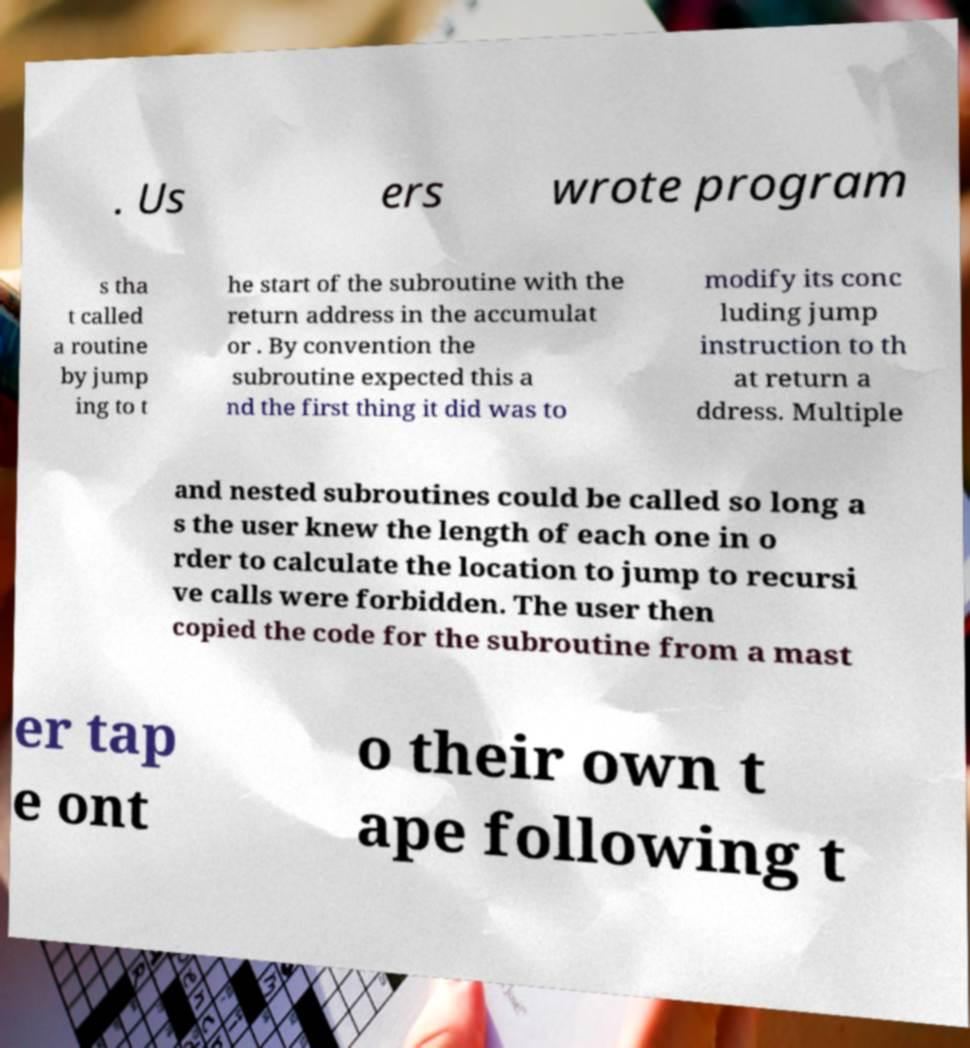Could you extract and type out the text from this image? . Us ers wrote program s tha t called a routine by jump ing to t he start of the subroutine with the return address in the accumulat or . By convention the subroutine expected this a nd the first thing it did was to modify its conc luding jump instruction to th at return a ddress. Multiple and nested subroutines could be called so long a s the user knew the length of each one in o rder to calculate the location to jump to recursi ve calls were forbidden. The user then copied the code for the subroutine from a mast er tap e ont o their own t ape following t 